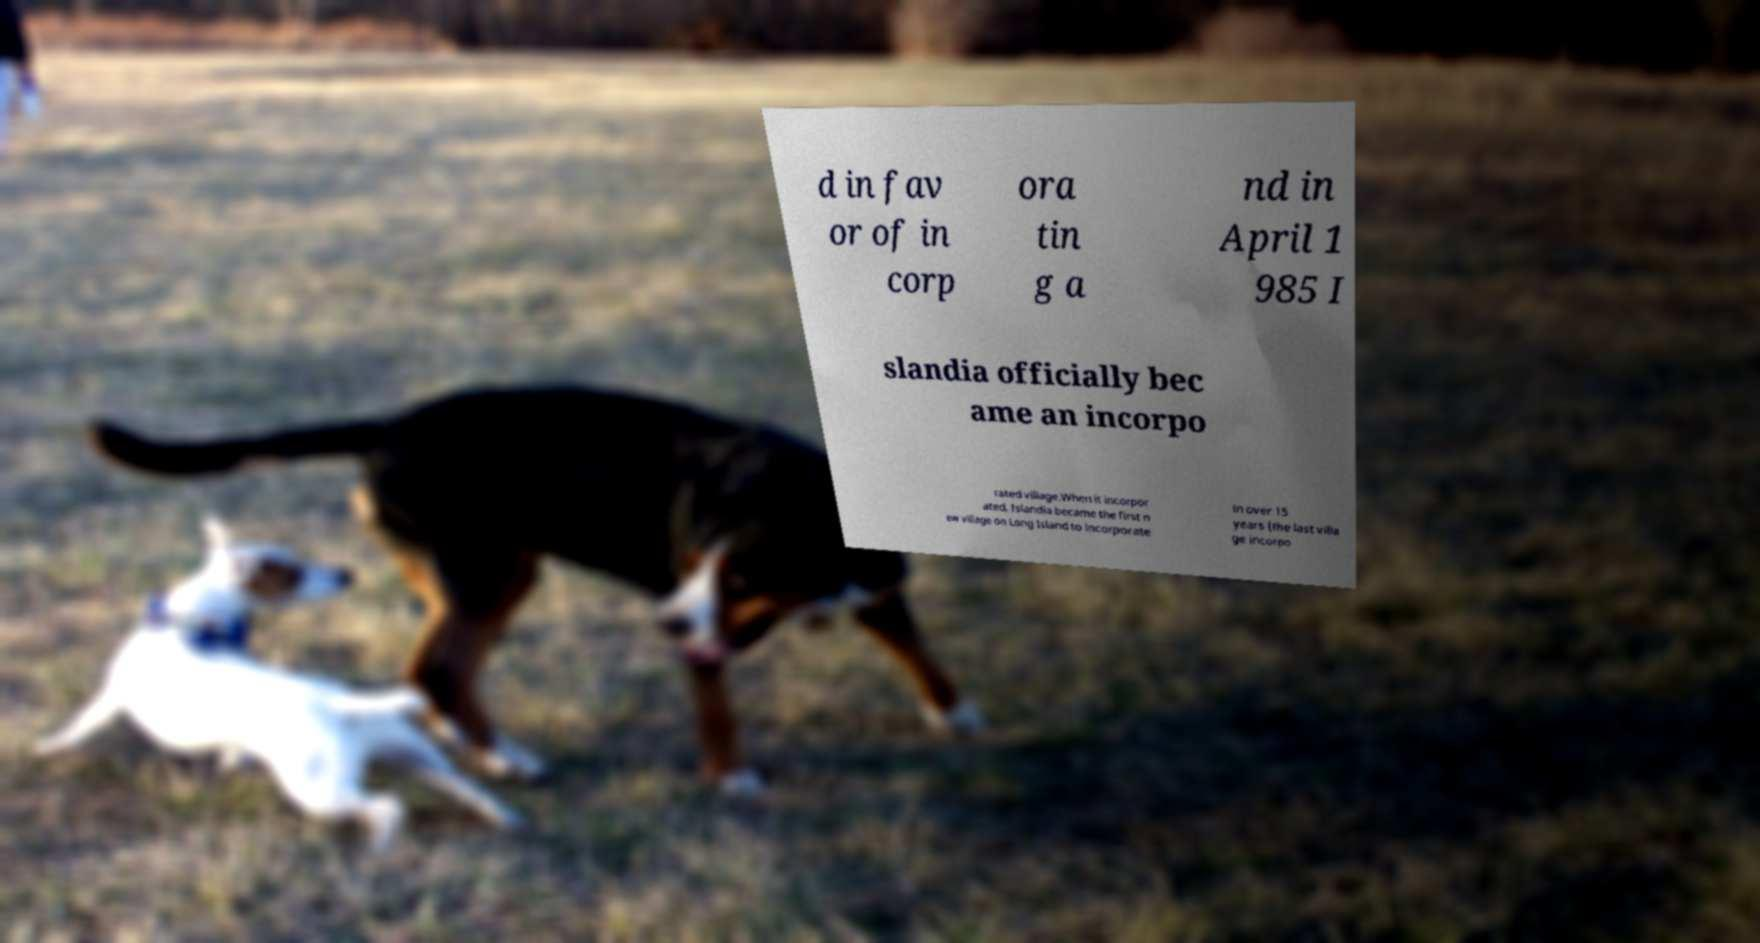Can you read and provide the text displayed in the image?This photo seems to have some interesting text. Can you extract and type it out for me? d in fav or of in corp ora tin g a nd in April 1 985 I slandia officially bec ame an incorpo rated village.When it incorpor ated, Islandia became the first n ew village on Long Island to incorporate in over 15 years (the last villa ge incorpo 